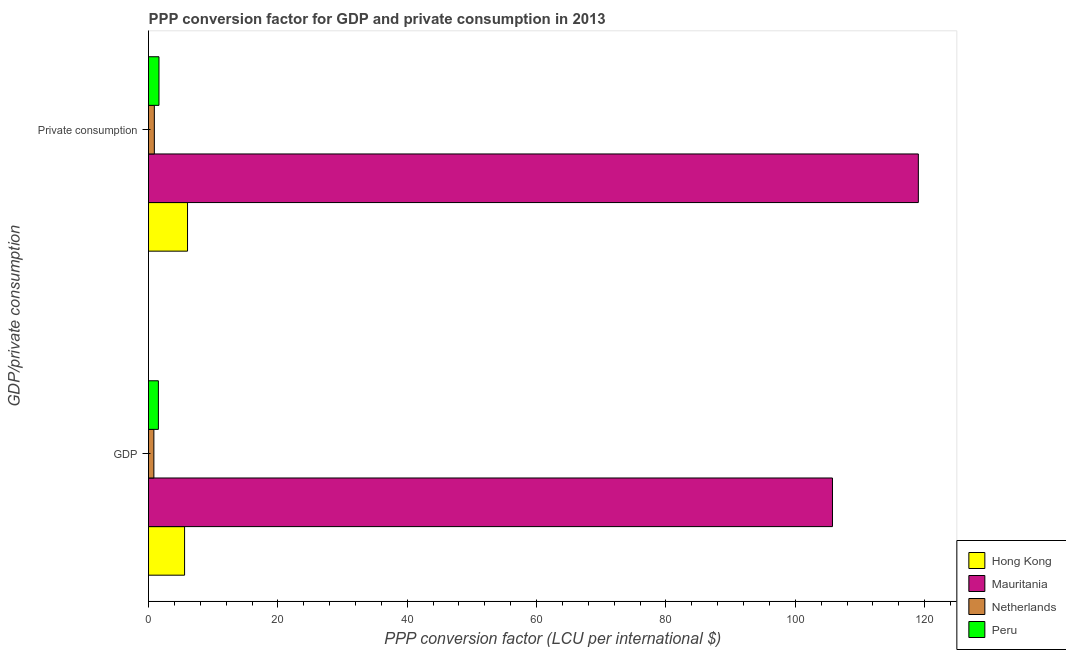How many different coloured bars are there?
Make the answer very short. 4. How many groups of bars are there?
Provide a succinct answer. 2. Are the number of bars per tick equal to the number of legend labels?
Your answer should be very brief. Yes. How many bars are there on the 1st tick from the bottom?
Offer a very short reply. 4. What is the label of the 1st group of bars from the top?
Offer a very short reply.  Private consumption. What is the ppp conversion factor for private consumption in Peru?
Provide a short and direct response. 1.61. Across all countries, what is the maximum ppp conversion factor for private consumption?
Ensure brevity in your answer.  119.02. Across all countries, what is the minimum ppp conversion factor for gdp?
Keep it short and to the point. 0.83. In which country was the ppp conversion factor for gdp maximum?
Offer a very short reply. Mauritania. What is the total ppp conversion factor for gdp in the graph?
Your answer should be compact. 113.67. What is the difference between the ppp conversion factor for private consumption in Hong Kong and that in Peru?
Offer a terse response. 4.42. What is the difference between the ppp conversion factor for gdp in Hong Kong and the ppp conversion factor for private consumption in Mauritania?
Your answer should be compact. -113.45. What is the average ppp conversion factor for private consumption per country?
Give a very brief answer. 31.89. What is the difference between the ppp conversion factor for gdp and ppp conversion factor for private consumption in Hong Kong?
Make the answer very short. -0.46. What is the ratio of the ppp conversion factor for private consumption in Mauritania to that in Peru?
Your response must be concise. 73.73. What does the 1st bar from the top in GDP represents?
Ensure brevity in your answer.  Peru. What does the 1st bar from the bottom in  Private consumption represents?
Keep it short and to the point. Hong Kong. How many bars are there?
Offer a very short reply. 8. What is the difference between two consecutive major ticks on the X-axis?
Give a very brief answer. 20. Are the values on the major ticks of X-axis written in scientific E-notation?
Ensure brevity in your answer.  No. Does the graph contain any zero values?
Your response must be concise. No. Where does the legend appear in the graph?
Your answer should be very brief. Bottom right. How many legend labels are there?
Your answer should be compact. 4. How are the legend labels stacked?
Give a very brief answer. Vertical. What is the title of the graph?
Your answer should be very brief. PPP conversion factor for GDP and private consumption in 2013. What is the label or title of the X-axis?
Your answer should be very brief. PPP conversion factor (LCU per international $). What is the label or title of the Y-axis?
Offer a very short reply. GDP/private consumption. What is the PPP conversion factor (LCU per international $) in Hong Kong in GDP?
Ensure brevity in your answer.  5.58. What is the PPP conversion factor (LCU per international $) in Mauritania in GDP?
Your response must be concise. 105.74. What is the PPP conversion factor (LCU per international $) in Netherlands in GDP?
Offer a terse response. 0.83. What is the PPP conversion factor (LCU per international $) of Peru in GDP?
Provide a short and direct response. 1.53. What is the PPP conversion factor (LCU per international $) of Hong Kong in  Private consumption?
Provide a succinct answer. 6.03. What is the PPP conversion factor (LCU per international $) of Mauritania in  Private consumption?
Make the answer very short. 119.02. What is the PPP conversion factor (LCU per international $) in Netherlands in  Private consumption?
Your answer should be very brief. 0.9. What is the PPP conversion factor (LCU per international $) in Peru in  Private consumption?
Offer a terse response. 1.61. Across all GDP/private consumption, what is the maximum PPP conversion factor (LCU per international $) of Hong Kong?
Offer a very short reply. 6.03. Across all GDP/private consumption, what is the maximum PPP conversion factor (LCU per international $) of Mauritania?
Provide a short and direct response. 119.02. Across all GDP/private consumption, what is the maximum PPP conversion factor (LCU per international $) in Netherlands?
Offer a terse response. 0.9. Across all GDP/private consumption, what is the maximum PPP conversion factor (LCU per international $) of Peru?
Your answer should be very brief. 1.61. Across all GDP/private consumption, what is the minimum PPP conversion factor (LCU per international $) in Hong Kong?
Ensure brevity in your answer.  5.58. Across all GDP/private consumption, what is the minimum PPP conversion factor (LCU per international $) of Mauritania?
Your answer should be very brief. 105.74. Across all GDP/private consumption, what is the minimum PPP conversion factor (LCU per international $) in Netherlands?
Keep it short and to the point. 0.83. Across all GDP/private consumption, what is the minimum PPP conversion factor (LCU per international $) in Peru?
Make the answer very short. 1.53. What is the total PPP conversion factor (LCU per international $) in Hong Kong in the graph?
Your response must be concise. 11.61. What is the total PPP conversion factor (LCU per international $) of Mauritania in the graph?
Your response must be concise. 224.76. What is the total PPP conversion factor (LCU per international $) of Netherlands in the graph?
Keep it short and to the point. 1.73. What is the total PPP conversion factor (LCU per international $) in Peru in the graph?
Give a very brief answer. 3.14. What is the difference between the PPP conversion factor (LCU per international $) in Hong Kong in GDP and that in  Private consumption?
Make the answer very short. -0.46. What is the difference between the PPP conversion factor (LCU per international $) of Mauritania in GDP and that in  Private consumption?
Your answer should be compact. -13.28. What is the difference between the PPP conversion factor (LCU per international $) of Netherlands in GDP and that in  Private consumption?
Give a very brief answer. -0.07. What is the difference between the PPP conversion factor (LCU per international $) of Peru in GDP and that in  Private consumption?
Offer a terse response. -0.09. What is the difference between the PPP conversion factor (LCU per international $) in Hong Kong in GDP and the PPP conversion factor (LCU per international $) in Mauritania in  Private consumption?
Keep it short and to the point. -113.45. What is the difference between the PPP conversion factor (LCU per international $) of Hong Kong in GDP and the PPP conversion factor (LCU per international $) of Netherlands in  Private consumption?
Provide a succinct answer. 4.68. What is the difference between the PPP conversion factor (LCU per international $) in Hong Kong in GDP and the PPP conversion factor (LCU per international $) in Peru in  Private consumption?
Keep it short and to the point. 3.96. What is the difference between the PPP conversion factor (LCU per international $) of Mauritania in GDP and the PPP conversion factor (LCU per international $) of Netherlands in  Private consumption?
Offer a terse response. 104.84. What is the difference between the PPP conversion factor (LCU per international $) in Mauritania in GDP and the PPP conversion factor (LCU per international $) in Peru in  Private consumption?
Give a very brief answer. 104.13. What is the difference between the PPP conversion factor (LCU per international $) in Netherlands in GDP and the PPP conversion factor (LCU per international $) in Peru in  Private consumption?
Offer a very short reply. -0.79. What is the average PPP conversion factor (LCU per international $) in Hong Kong per GDP/private consumption?
Your answer should be very brief. 5.8. What is the average PPP conversion factor (LCU per international $) of Mauritania per GDP/private consumption?
Give a very brief answer. 112.38. What is the average PPP conversion factor (LCU per international $) of Netherlands per GDP/private consumption?
Offer a terse response. 0.86. What is the average PPP conversion factor (LCU per international $) in Peru per GDP/private consumption?
Give a very brief answer. 1.57. What is the difference between the PPP conversion factor (LCU per international $) of Hong Kong and PPP conversion factor (LCU per international $) of Mauritania in GDP?
Ensure brevity in your answer.  -100.17. What is the difference between the PPP conversion factor (LCU per international $) of Hong Kong and PPP conversion factor (LCU per international $) of Netherlands in GDP?
Your answer should be very brief. 4.75. What is the difference between the PPP conversion factor (LCU per international $) in Hong Kong and PPP conversion factor (LCU per international $) in Peru in GDP?
Provide a short and direct response. 4.05. What is the difference between the PPP conversion factor (LCU per international $) in Mauritania and PPP conversion factor (LCU per international $) in Netherlands in GDP?
Your response must be concise. 104.91. What is the difference between the PPP conversion factor (LCU per international $) of Mauritania and PPP conversion factor (LCU per international $) of Peru in GDP?
Ensure brevity in your answer.  104.22. What is the difference between the PPP conversion factor (LCU per international $) of Netherlands and PPP conversion factor (LCU per international $) of Peru in GDP?
Your response must be concise. -0.7. What is the difference between the PPP conversion factor (LCU per international $) of Hong Kong and PPP conversion factor (LCU per international $) of Mauritania in  Private consumption?
Provide a short and direct response. -112.99. What is the difference between the PPP conversion factor (LCU per international $) in Hong Kong and PPP conversion factor (LCU per international $) in Netherlands in  Private consumption?
Provide a short and direct response. 5.13. What is the difference between the PPP conversion factor (LCU per international $) in Hong Kong and PPP conversion factor (LCU per international $) in Peru in  Private consumption?
Provide a short and direct response. 4.42. What is the difference between the PPP conversion factor (LCU per international $) in Mauritania and PPP conversion factor (LCU per international $) in Netherlands in  Private consumption?
Provide a short and direct response. 118.12. What is the difference between the PPP conversion factor (LCU per international $) in Mauritania and PPP conversion factor (LCU per international $) in Peru in  Private consumption?
Your response must be concise. 117.41. What is the difference between the PPP conversion factor (LCU per international $) in Netherlands and PPP conversion factor (LCU per international $) in Peru in  Private consumption?
Offer a very short reply. -0.71. What is the ratio of the PPP conversion factor (LCU per international $) in Hong Kong in GDP to that in  Private consumption?
Provide a succinct answer. 0.92. What is the ratio of the PPP conversion factor (LCU per international $) in Mauritania in GDP to that in  Private consumption?
Ensure brevity in your answer.  0.89. What is the ratio of the PPP conversion factor (LCU per international $) of Netherlands in GDP to that in  Private consumption?
Provide a succinct answer. 0.92. What is the ratio of the PPP conversion factor (LCU per international $) in Peru in GDP to that in  Private consumption?
Offer a very short reply. 0.95. What is the difference between the highest and the second highest PPP conversion factor (LCU per international $) in Hong Kong?
Give a very brief answer. 0.46. What is the difference between the highest and the second highest PPP conversion factor (LCU per international $) in Mauritania?
Keep it short and to the point. 13.28. What is the difference between the highest and the second highest PPP conversion factor (LCU per international $) of Netherlands?
Provide a succinct answer. 0.07. What is the difference between the highest and the second highest PPP conversion factor (LCU per international $) of Peru?
Offer a terse response. 0.09. What is the difference between the highest and the lowest PPP conversion factor (LCU per international $) of Hong Kong?
Give a very brief answer. 0.46. What is the difference between the highest and the lowest PPP conversion factor (LCU per international $) of Mauritania?
Your answer should be very brief. 13.28. What is the difference between the highest and the lowest PPP conversion factor (LCU per international $) in Netherlands?
Offer a terse response. 0.07. What is the difference between the highest and the lowest PPP conversion factor (LCU per international $) in Peru?
Offer a terse response. 0.09. 